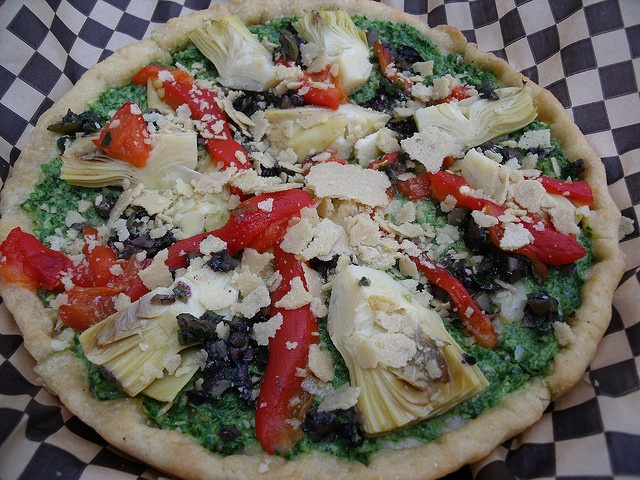Describe the objects in this image and their specific colors. I can see pizza in black, darkgray, and gray tones and pizza in black, darkgray, and gray tones in this image. 